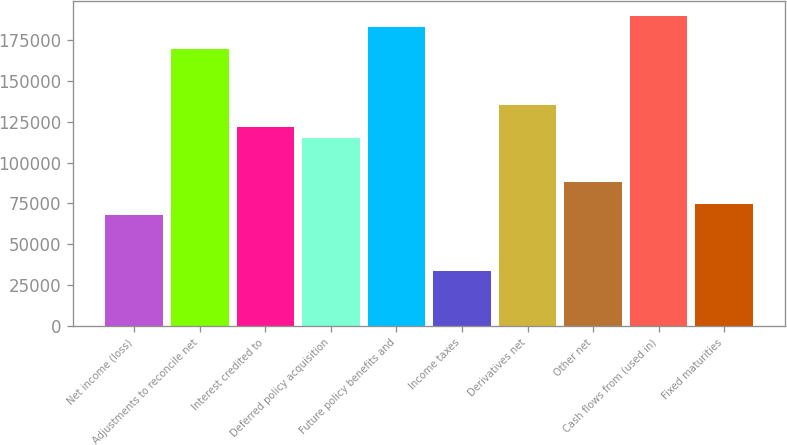<chart> <loc_0><loc_0><loc_500><loc_500><bar_chart><fcel>Net income (loss)<fcel>Adjustments to reconcile net<fcel>Interest credited to<fcel>Deferred policy acquisition<fcel>Future policy benefits and<fcel>Income taxes<fcel>Derivatives net<fcel>Other net<fcel>Cash flows from (used in)<fcel>Fixed maturities<nl><fcel>67774<fcel>169431<fcel>121991<fcel>115214<fcel>182985<fcel>33888.4<fcel>135545<fcel>88105.4<fcel>189762<fcel>74551.1<nl></chart> 